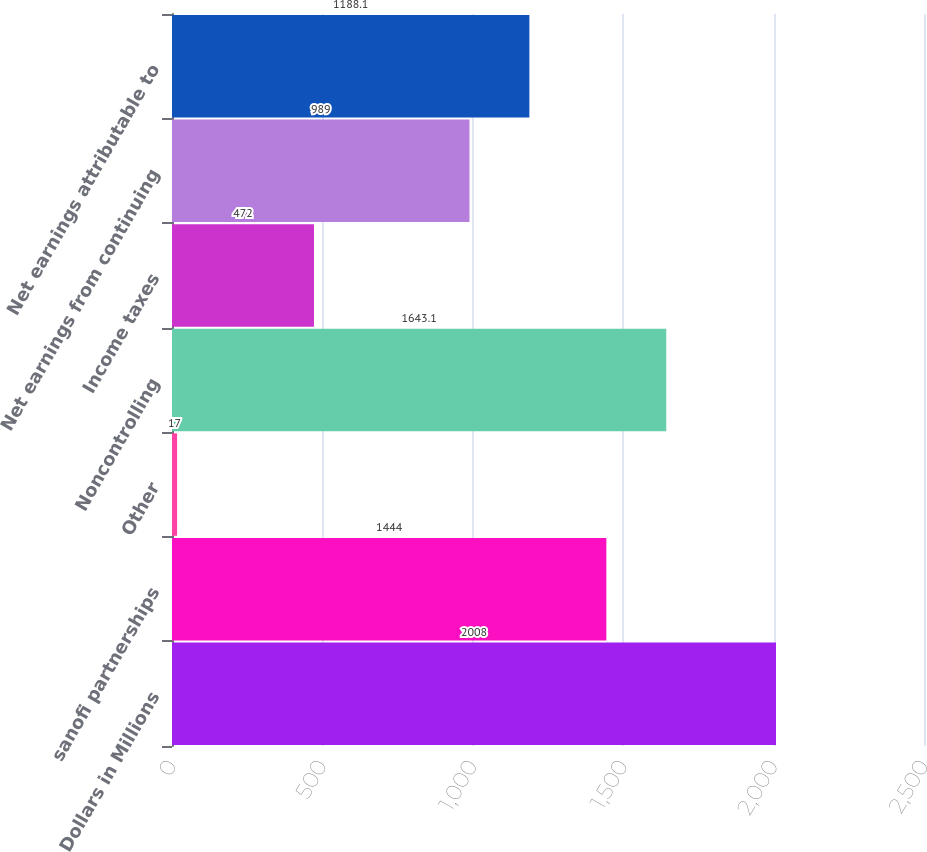<chart> <loc_0><loc_0><loc_500><loc_500><bar_chart><fcel>Dollars in Millions<fcel>sanofi partnerships<fcel>Other<fcel>Noncontrolling<fcel>Income taxes<fcel>Net earnings from continuing<fcel>Net earnings attributable to<nl><fcel>2008<fcel>1444<fcel>17<fcel>1643.1<fcel>472<fcel>989<fcel>1188.1<nl></chart> 